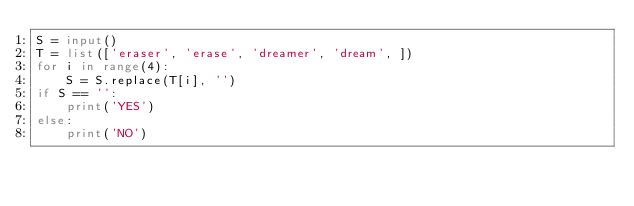Convert code to text. <code><loc_0><loc_0><loc_500><loc_500><_Python_>S = input()
T = list(['eraser', 'erase', 'dreamer', 'dream', ])
for i in range(4):
    S = S.replace(T[i], '')
if S == '':
    print('YES')
else:
    print('NO')</code> 